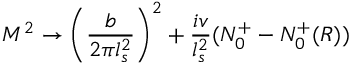Convert formula to latex. <formula><loc_0><loc_0><loc_500><loc_500>M ^ { 2 } \rightarrow \left ( { \frac { b } { 2 \pi l _ { s } ^ { 2 } } } \right ) ^ { 2 } + { \frac { i v } { l _ { s } ^ { 2 } } } ( N _ { 0 } ^ { + } - N _ { 0 } ^ { + } ( R ) )</formula> 